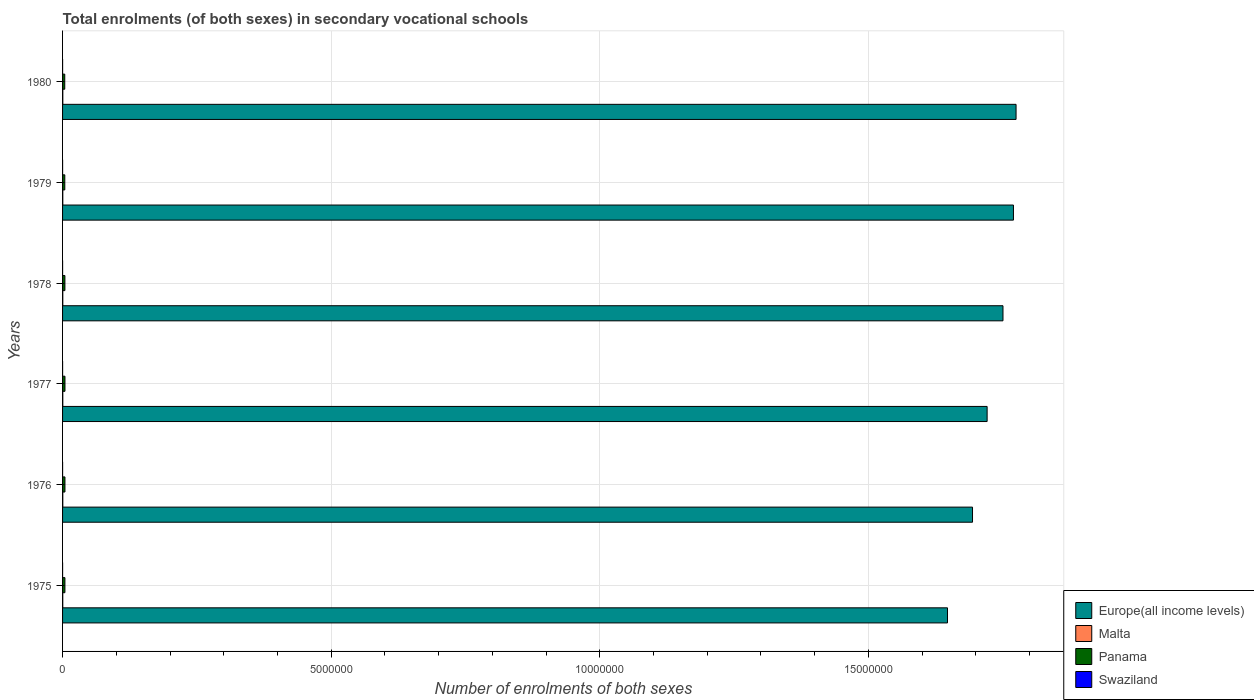How many bars are there on the 4th tick from the top?
Make the answer very short. 4. How many bars are there on the 6th tick from the bottom?
Make the answer very short. 4. What is the label of the 5th group of bars from the top?
Make the answer very short. 1976. What is the number of enrolments in secondary schools in Europe(all income levels) in 1976?
Your answer should be compact. 1.69e+07. Across all years, what is the maximum number of enrolments in secondary schools in Swaziland?
Offer a terse response. 649. Across all years, what is the minimum number of enrolments in secondary schools in Europe(all income levels)?
Your response must be concise. 1.65e+07. In which year was the number of enrolments in secondary schools in Swaziland maximum?
Provide a succinct answer. 1975. In which year was the number of enrolments in secondary schools in Malta minimum?
Ensure brevity in your answer.  1975. What is the total number of enrolments in secondary schools in Swaziland in the graph?
Provide a succinct answer. 2801. What is the difference between the number of enrolments in secondary schools in Europe(all income levels) in 1975 and that in 1978?
Offer a terse response. -1.03e+06. What is the difference between the number of enrolments in secondary schools in Malta in 1975 and the number of enrolments in secondary schools in Europe(all income levels) in 1976?
Provide a short and direct response. -1.69e+07. What is the average number of enrolments in secondary schools in Panama per year?
Your answer should be compact. 4.31e+04. In the year 1979, what is the difference between the number of enrolments in secondary schools in Malta and number of enrolments in secondary schools in Europe(all income levels)?
Provide a succinct answer. -1.77e+07. What is the ratio of the number of enrolments in secondary schools in Panama in 1975 to that in 1980?
Your answer should be compact. 1.07. Is the difference between the number of enrolments in secondary schools in Malta in 1977 and 1980 greater than the difference between the number of enrolments in secondary schools in Europe(all income levels) in 1977 and 1980?
Provide a short and direct response. Yes. What is the difference between the highest and the second highest number of enrolments in secondary schools in Malta?
Give a very brief answer. 231. What is the difference between the highest and the lowest number of enrolments in secondary schools in Swaziland?
Provide a succinct answer. 246. In how many years, is the number of enrolments in secondary schools in Europe(all income levels) greater than the average number of enrolments in secondary schools in Europe(all income levels) taken over all years?
Give a very brief answer. 3. Is the sum of the number of enrolments in secondary schools in Panama in 1975 and 1979 greater than the maximum number of enrolments in secondary schools in Swaziland across all years?
Your answer should be compact. Yes. What does the 3rd bar from the top in 1980 represents?
Offer a very short reply. Malta. What does the 4th bar from the bottom in 1979 represents?
Keep it short and to the point. Swaziland. Are all the bars in the graph horizontal?
Ensure brevity in your answer.  Yes. Does the graph contain any zero values?
Your answer should be very brief. No. What is the title of the graph?
Make the answer very short. Total enrolments (of both sexes) in secondary vocational schools. What is the label or title of the X-axis?
Keep it short and to the point. Number of enrolments of both sexes. What is the label or title of the Y-axis?
Provide a succinct answer. Years. What is the Number of enrolments of both sexes of Europe(all income levels) in 1975?
Provide a succinct answer. 1.65e+07. What is the Number of enrolments of both sexes of Malta in 1975?
Your answer should be very brief. 3663. What is the Number of enrolments of both sexes of Panama in 1975?
Your answer should be compact. 4.38e+04. What is the Number of enrolments of both sexes of Swaziland in 1975?
Give a very brief answer. 649. What is the Number of enrolments of both sexes of Europe(all income levels) in 1976?
Your response must be concise. 1.69e+07. What is the Number of enrolments of both sexes of Malta in 1976?
Offer a terse response. 4387. What is the Number of enrolments of both sexes in Panama in 1976?
Your answer should be very brief. 4.44e+04. What is the Number of enrolments of both sexes of Swaziland in 1976?
Your response must be concise. 472. What is the Number of enrolments of both sexes in Europe(all income levels) in 1977?
Provide a succinct answer. 1.72e+07. What is the Number of enrolments of both sexes of Malta in 1977?
Give a very brief answer. 4332. What is the Number of enrolments of both sexes in Panama in 1977?
Offer a terse response. 4.48e+04. What is the Number of enrolments of both sexes in Swaziland in 1977?
Your answer should be compact. 403. What is the Number of enrolments of both sexes in Europe(all income levels) in 1978?
Your response must be concise. 1.75e+07. What is the Number of enrolments of both sexes in Malta in 1978?
Offer a very short reply. 4397. What is the Number of enrolments of both sexes of Panama in 1978?
Provide a succinct answer. 4.35e+04. What is the Number of enrolments of both sexes of Swaziland in 1978?
Provide a short and direct response. 406. What is the Number of enrolments of both sexes in Europe(all income levels) in 1979?
Your response must be concise. 1.77e+07. What is the Number of enrolments of both sexes of Malta in 1979?
Your answer should be very brief. 4395. What is the Number of enrolments of both sexes of Panama in 1979?
Ensure brevity in your answer.  4.15e+04. What is the Number of enrolments of both sexes of Swaziland in 1979?
Provide a succinct answer. 404. What is the Number of enrolments of both sexes in Europe(all income levels) in 1980?
Make the answer very short. 1.78e+07. What is the Number of enrolments of both sexes in Malta in 1980?
Your answer should be compact. 4628. What is the Number of enrolments of both sexes in Panama in 1980?
Offer a very short reply. 4.08e+04. What is the Number of enrolments of both sexes in Swaziland in 1980?
Offer a terse response. 467. Across all years, what is the maximum Number of enrolments of both sexes in Europe(all income levels)?
Offer a terse response. 1.78e+07. Across all years, what is the maximum Number of enrolments of both sexes in Malta?
Make the answer very short. 4628. Across all years, what is the maximum Number of enrolments of both sexes in Panama?
Your response must be concise. 4.48e+04. Across all years, what is the maximum Number of enrolments of both sexes of Swaziland?
Your answer should be very brief. 649. Across all years, what is the minimum Number of enrolments of both sexes in Europe(all income levels)?
Ensure brevity in your answer.  1.65e+07. Across all years, what is the minimum Number of enrolments of both sexes of Malta?
Provide a succinct answer. 3663. Across all years, what is the minimum Number of enrolments of both sexes of Panama?
Offer a terse response. 4.08e+04. Across all years, what is the minimum Number of enrolments of both sexes in Swaziland?
Provide a short and direct response. 403. What is the total Number of enrolments of both sexes in Europe(all income levels) in the graph?
Offer a terse response. 1.04e+08. What is the total Number of enrolments of both sexes in Malta in the graph?
Your response must be concise. 2.58e+04. What is the total Number of enrolments of both sexes of Panama in the graph?
Provide a short and direct response. 2.59e+05. What is the total Number of enrolments of both sexes of Swaziland in the graph?
Provide a succinct answer. 2801. What is the difference between the Number of enrolments of both sexes of Europe(all income levels) in 1975 and that in 1976?
Ensure brevity in your answer.  -4.66e+05. What is the difference between the Number of enrolments of both sexes of Malta in 1975 and that in 1976?
Offer a terse response. -724. What is the difference between the Number of enrolments of both sexes in Panama in 1975 and that in 1976?
Provide a short and direct response. -632. What is the difference between the Number of enrolments of both sexes in Swaziland in 1975 and that in 1976?
Your response must be concise. 177. What is the difference between the Number of enrolments of both sexes in Europe(all income levels) in 1975 and that in 1977?
Provide a succinct answer. -7.38e+05. What is the difference between the Number of enrolments of both sexes in Malta in 1975 and that in 1977?
Offer a terse response. -669. What is the difference between the Number of enrolments of both sexes in Panama in 1975 and that in 1977?
Ensure brevity in your answer.  -1005. What is the difference between the Number of enrolments of both sexes in Swaziland in 1975 and that in 1977?
Ensure brevity in your answer.  246. What is the difference between the Number of enrolments of both sexes in Europe(all income levels) in 1975 and that in 1978?
Keep it short and to the point. -1.03e+06. What is the difference between the Number of enrolments of both sexes in Malta in 1975 and that in 1978?
Your answer should be very brief. -734. What is the difference between the Number of enrolments of both sexes of Panama in 1975 and that in 1978?
Offer a very short reply. 308. What is the difference between the Number of enrolments of both sexes in Swaziland in 1975 and that in 1978?
Make the answer very short. 243. What is the difference between the Number of enrolments of both sexes in Europe(all income levels) in 1975 and that in 1979?
Offer a terse response. -1.23e+06. What is the difference between the Number of enrolments of both sexes of Malta in 1975 and that in 1979?
Your answer should be very brief. -732. What is the difference between the Number of enrolments of both sexes in Panama in 1975 and that in 1979?
Keep it short and to the point. 2306. What is the difference between the Number of enrolments of both sexes of Swaziland in 1975 and that in 1979?
Make the answer very short. 245. What is the difference between the Number of enrolments of both sexes in Europe(all income levels) in 1975 and that in 1980?
Provide a short and direct response. -1.28e+06. What is the difference between the Number of enrolments of both sexes of Malta in 1975 and that in 1980?
Offer a very short reply. -965. What is the difference between the Number of enrolments of both sexes in Panama in 1975 and that in 1980?
Ensure brevity in your answer.  3040. What is the difference between the Number of enrolments of both sexes of Swaziland in 1975 and that in 1980?
Offer a very short reply. 182. What is the difference between the Number of enrolments of both sexes in Europe(all income levels) in 1976 and that in 1977?
Keep it short and to the point. -2.72e+05. What is the difference between the Number of enrolments of both sexes in Panama in 1976 and that in 1977?
Keep it short and to the point. -373. What is the difference between the Number of enrolments of both sexes in Europe(all income levels) in 1976 and that in 1978?
Your response must be concise. -5.67e+05. What is the difference between the Number of enrolments of both sexes in Panama in 1976 and that in 1978?
Give a very brief answer. 940. What is the difference between the Number of enrolments of both sexes of Europe(all income levels) in 1976 and that in 1979?
Your answer should be compact. -7.62e+05. What is the difference between the Number of enrolments of both sexes of Malta in 1976 and that in 1979?
Ensure brevity in your answer.  -8. What is the difference between the Number of enrolments of both sexes of Panama in 1976 and that in 1979?
Your answer should be very brief. 2938. What is the difference between the Number of enrolments of both sexes of Europe(all income levels) in 1976 and that in 1980?
Offer a terse response. -8.11e+05. What is the difference between the Number of enrolments of both sexes of Malta in 1976 and that in 1980?
Give a very brief answer. -241. What is the difference between the Number of enrolments of both sexes of Panama in 1976 and that in 1980?
Give a very brief answer. 3672. What is the difference between the Number of enrolments of both sexes in Swaziland in 1976 and that in 1980?
Ensure brevity in your answer.  5. What is the difference between the Number of enrolments of both sexes in Europe(all income levels) in 1977 and that in 1978?
Ensure brevity in your answer.  -2.95e+05. What is the difference between the Number of enrolments of both sexes in Malta in 1977 and that in 1978?
Keep it short and to the point. -65. What is the difference between the Number of enrolments of both sexes of Panama in 1977 and that in 1978?
Keep it short and to the point. 1313. What is the difference between the Number of enrolments of both sexes of Europe(all income levels) in 1977 and that in 1979?
Make the answer very short. -4.90e+05. What is the difference between the Number of enrolments of both sexes of Malta in 1977 and that in 1979?
Provide a short and direct response. -63. What is the difference between the Number of enrolments of both sexes of Panama in 1977 and that in 1979?
Keep it short and to the point. 3311. What is the difference between the Number of enrolments of both sexes of Europe(all income levels) in 1977 and that in 1980?
Ensure brevity in your answer.  -5.39e+05. What is the difference between the Number of enrolments of both sexes in Malta in 1977 and that in 1980?
Offer a terse response. -296. What is the difference between the Number of enrolments of both sexes of Panama in 1977 and that in 1980?
Provide a short and direct response. 4045. What is the difference between the Number of enrolments of both sexes in Swaziland in 1977 and that in 1980?
Offer a very short reply. -64. What is the difference between the Number of enrolments of both sexes of Europe(all income levels) in 1978 and that in 1979?
Your answer should be compact. -1.95e+05. What is the difference between the Number of enrolments of both sexes in Malta in 1978 and that in 1979?
Offer a terse response. 2. What is the difference between the Number of enrolments of both sexes of Panama in 1978 and that in 1979?
Provide a short and direct response. 1998. What is the difference between the Number of enrolments of both sexes of Swaziland in 1978 and that in 1979?
Offer a very short reply. 2. What is the difference between the Number of enrolments of both sexes of Europe(all income levels) in 1978 and that in 1980?
Your answer should be very brief. -2.43e+05. What is the difference between the Number of enrolments of both sexes of Malta in 1978 and that in 1980?
Make the answer very short. -231. What is the difference between the Number of enrolments of both sexes in Panama in 1978 and that in 1980?
Keep it short and to the point. 2732. What is the difference between the Number of enrolments of both sexes of Swaziland in 1978 and that in 1980?
Keep it short and to the point. -61. What is the difference between the Number of enrolments of both sexes of Europe(all income levels) in 1979 and that in 1980?
Give a very brief answer. -4.86e+04. What is the difference between the Number of enrolments of both sexes of Malta in 1979 and that in 1980?
Offer a terse response. -233. What is the difference between the Number of enrolments of both sexes of Panama in 1979 and that in 1980?
Ensure brevity in your answer.  734. What is the difference between the Number of enrolments of both sexes in Swaziland in 1979 and that in 1980?
Provide a succinct answer. -63. What is the difference between the Number of enrolments of both sexes in Europe(all income levels) in 1975 and the Number of enrolments of both sexes in Malta in 1976?
Provide a succinct answer. 1.65e+07. What is the difference between the Number of enrolments of both sexes in Europe(all income levels) in 1975 and the Number of enrolments of both sexes in Panama in 1976?
Offer a very short reply. 1.64e+07. What is the difference between the Number of enrolments of both sexes in Europe(all income levels) in 1975 and the Number of enrolments of both sexes in Swaziland in 1976?
Ensure brevity in your answer.  1.65e+07. What is the difference between the Number of enrolments of both sexes in Malta in 1975 and the Number of enrolments of both sexes in Panama in 1976?
Give a very brief answer. -4.08e+04. What is the difference between the Number of enrolments of both sexes in Malta in 1975 and the Number of enrolments of both sexes in Swaziland in 1976?
Your answer should be compact. 3191. What is the difference between the Number of enrolments of both sexes of Panama in 1975 and the Number of enrolments of both sexes of Swaziland in 1976?
Your response must be concise. 4.33e+04. What is the difference between the Number of enrolments of both sexes of Europe(all income levels) in 1975 and the Number of enrolments of both sexes of Malta in 1977?
Your answer should be very brief. 1.65e+07. What is the difference between the Number of enrolments of both sexes of Europe(all income levels) in 1975 and the Number of enrolments of both sexes of Panama in 1977?
Your answer should be very brief. 1.64e+07. What is the difference between the Number of enrolments of both sexes of Europe(all income levels) in 1975 and the Number of enrolments of both sexes of Swaziland in 1977?
Give a very brief answer. 1.65e+07. What is the difference between the Number of enrolments of both sexes in Malta in 1975 and the Number of enrolments of both sexes in Panama in 1977?
Ensure brevity in your answer.  -4.12e+04. What is the difference between the Number of enrolments of both sexes of Malta in 1975 and the Number of enrolments of both sexes of Swaziland in 1977?
Offer a terse response. 3260. What is the difference between the Number of enrolments of both sexes of Panama in 1975 and the Number of enrolments of both sexes of Swaziland in 1977?
Your answer should be compact. 4.34e+04. What is the difference between the Number of enrolments of both sexes of Europe(all income levels) in 1975 and the Number of enrolments of both sexes of Malta in 1978?
Give a very brief answer. 1.65e+07. What is the difference between the Number of enrolments of both sexes of Europe(all income levels) in 1975 and the Number of enrolments of both sexes of Panama in 1978?
Provide a short and direct response. 1.64e+07. What is the difference between the Number of enrolments of both sexes of Europe(all income levels) in 1975 and the Number of enrolments of both sexes of Swaziland in 1978?
Provide a succinct answer. 1.65e+07. What is the difference between the Number of enrolments of both sexes in Malta in 1975 and the Number of enrolments of both sexes in Panama in 1978?
Give a very brief answer. -3.98e+04. What is the difference between the Number of enrolments of both sexes in Malta in 1975 and the Number of enrolments of both sexes in Swaziland in 1978?
Offer a terse response. 3257. What is the difference between the Number of enrolments of both sexes in Panama in 1975 and the Number of enrolments of both sexes in Swaziland in 1978?
Offer a terse response. 4.34e+04. What is the difference between the Number of enrolments of both sexes of Europe(all income levels) in 1975 and the Number of enrolments of both sexes of Malta in 1979?
Your answer should be compact. 1.65e+07. What is the difference between the Number of enrolments of both sexes in Europe(all income levels) in 1975 and the Number of enrolments of both sexes in Panama in 1979?
Provide a succinct answer. 1.64e+07. What is the difference between the Number of enrolments of both sexes in Europe(all income levels) in 1975 and the Number of enrolments of both sexes in Swaziland in 1979?
Provide a short and direct response. 1.65e+07. What is the difference between the Number of enrolments of both sexes in Malta in 1975 and the Number of enrolments of both sexes in Panama in 1979?
Your answer should be very brief. -3.78e+04. What is the difference between the Number of enrolments of both sexes in Malta in 1975 and the Number of enrolments of both sexes in Swaziland in 1979?
Your answer should be compact. 3259. What is the difference between the Number of enrolments of both sexes of Panama in 1975 and the Number of enrolments of both sexes of Swaziland in 1979?
Offer a very short reply. 4.34e+04. What is the difference between the Number of enrolments of both sexes in Europe(all income levels) in 1975 and the Number of enrolments of both sexes in Malta in 1980?
Provide a succinct answer. 1.65e+07. What is the difference between the Number of enrolments of both sexes of Europe(all income levels) in 1975 and the Number of enrolments of both sexes of Panama in 1980?
Provide a succinct answer. 1.64e+07. What is the difference between the Number of enrolments of both sexes of Europe(all income levels) in 1975 and the Number of enrolments of both sexes of Swaziland in 1980?
Keep it short and to the point. 1.65e+07. What is the difference between the Number of enrolments of both sexes of Malta in 1975 and the Number of enrolments of both sexes of Panama in 1980?
Give a very brief answer. -3.71e+04. What is the difference between the Number of enrolments of both sexes in Malta in 1975 and the Number of enrolments of both sexes in Swaziland in 1980?
Offer a terse response. 3196. What is the difference between the Number of enrolments of both sexes in Panama in 1975 and the Number of enrolments of both sexes in Swaziland in 1980?
Offer a terse response. 4.34e+04. What is the difference between the Number of enrolments of both sexes of Europe(all income levels) in 1976 and the Number of enrolments of both sexes of Malta in 1977?
Offer a terse response. 1.69e+07. What is the difference between the Number of enrolments of both sexes in Europe(all income levels) in 1976 and the Number of enrolments of both sexes in Panama in 1977?
Keep it short and to the point. 1.69e+07. What is the difference between the Number of enrolments of both sexes in Europe(all income levels) in 1976 and the Number of enrolments of both sexes in Swaziland in 1977?
Give a very brief answer. 1.69e+07. What is the difference between the Number of enrolments of both sexes in Malta in 1976 and the Number of enrolments of both sexes in Panama in 1977?
Provide a short and direct response. -4.04e+04. What is the difference between the Number of enrolments of both sexes of Malta in 1976 and the Number of enrolments of both sexes of Swaziland in 1977?
Ensure brevity in your answer.  3984. What is the difference between the Number of enrolments of both sexes of Panama in 1976 and the Number of enrolments of both sexes of Swaziland in 1977?
Your response must be concise. 4.40e+04. What is the difference between the Number of enrolments of both sexes of Europe(all income levels) in 1976 and the Number of enrolments of both sexes of Malta in 1978?
Make the answer very short. 1.69e+07. What is the difference between the Number of enrolments of both sexes of Europe(all income levels) in 1976 and the Number of enrolments of both sexes of Panama in 1978?
Provide a short and direct response. 1.69e+07. What is the difference between the Number of enrolments of both sexes of Europe(all income levels) in 1976 and the Number of enrolments of both sexes of Swaziland in 1978?
Offer a very short reply. 1.69e+07. What is the difference between the Number of enrolments of both sexes in Malta in 1976 and the Number of enrolments of both sexes in Panama in 1978?
Provide a succinct answer. -3.91e+04. What is the difference between the Number of enrolments of both sexes of Malta in 1976 and the Number of enrolments of both sexes of Swaziland in 1978?
Your answer should be compact. 3981. What is the difference between the Number of enrolments of both sexes of Panama in 1976 and the Number of enrolments of both sexes of Swaziland in 1978?
Provide a short and direct response. 4.40e+04. What is the difference between the Number of enrolments of both sexes of Europe(all income levels) in 1976 and the Number of enrolments of both sexes of Malta in 1979?
Provide a succinct answer. 1.69e+07. What is the difference between the Number of enrolments of both sexes in Europe(all income levels) in 1976 and the Number of enrolments of both sexes in Panama in 1979?
Make the answer very short. 1.69e+07. What is the difference between the Number of enrolments of both sexes in Europe(all income levels) in 1976 and the Number of enrolments of both sexes in Swaziland in 1979?
Give a very brief answer. 1.69e+07. What is the difference between the Number of enrolments of both sexes in Malta in 1976 and the Number of enrolments of both sexes in Panama in 1979?
Give a very brief answer. -3.71e+04. What is the difference between the Number of enrolments of both sexes of Malta in 1976 and the Number of enrolments of both sexes of Swaziland in 1979?
Make the answer very short. 3983. What is the difference between the Number of enrolments of both sexes in Panama in 1976 and the Number of enrolments of both sexes in Swaziland in 1979?
Ensure brevity in your answer.  4.40e+04. What is the difference between the Number of enrolments of both sexes in Europe(all income levels) in 1976 and the Number of enrolments of both sexes in Malta in 1980?
Keep it short and to the point. 1.69e+07. What is the difference between the Number of enrolments of both sexes of Europe(all income levels) in 1976 and the Number of enrolments of both sexes of Panama in 1980?
Offer a very short reply. 1.69e+07. What is the difference between the Number of enrolments of both sexes of Europe(all income levels) in 1976 and the Number of enrolments of both sexes of Swaziland in 1980?
Give a very brief answer. 1.69e+07. What is the difference between the Number of enrolments of both sexes in Malta in 1976 and the Number of enrolments of both sexes in Panama in 1980?
Give a very brief answer. -3.64e+04. What is the difference between the Number of enrolments of both sexes in Malta in 1976 and the Number of enrolments of both sexes in Swaziland in 1980?
Provide a short and direct response. 3920. What is the difference between the Number of enrolments of both sexes of Panama in 1976 and the Number of enrolments of both sexes of Swaziland in 1980?
Ensure brevity in your answer.  4.40e+04. What is the difference between the Number of enrolments of both sexes in Europe(all income levels) in 1977 and the Number of enrolments of both sexes in Malta in 1978?
Provide a short and direct response. 1.72e+07. What is the difference between the Number of enrolments of both sexes of Europe(all income levels) in 1977 and the Number of enrolments of both sexes of Panama in 1978?
Give a very brief answer. 1.72e+07. What is the difference between the Number of enrolments of both sexes in Europe(all income levels) in 1977 and the Number of enrolments of both sexes in Swaziland in 1978?
Provide a succinct answer. 1.72e+07. What is the difference between the Number of enrolments of both sexes in Malta in 1977 and the Number of enrolments of both sexes in Panama in 1978?
Offer a terse response. -3.92e+04. What is the difference between the Number of enrolments of both sexes in Malta in 1977 and the Number of enrolments of both sexes in Swaziland in 1978?
Keep it short and to the point. 3926. What is the difference between the Number of enrolments of both sexes in Panama in 1977 and the Number of enrolments of both sexes in Swaziland in 1978?
Make the answer very short. 4.44e+04. What is the difference between the Number of enrolments of both sexes of Europe(all income levels) in 1977 and the Number of enrolments of both sexes of Malta in 1979?
Provide a succinct answer. 1.72e+07. What is the difference between the Number of enrolments of both sexes in Europe(all income levels) in 1977 and the Number of enrolments of both sexes in Panama in 1979?
Keep it short and to the point. 1.72e+07. What is the difference between the Number of enrolments of both sexes in Europe(all income levels) in 1977 and the Number of enrolments of both sexes in Swaziland in 1979?
Give a very brief answer. 1.72e+07. What is the difference between the Number of enrolments of both sexes in Malta in 1977 and the Number of enrolments of both sexes in Panama in 1979?
Offer a terse response. -3.72e+04. What is the difference between the Number of enrolments of both sexes of Malta in 1977 and the Number of enrolments of both sexes of Swaziland in 1979?
Offer a terse response. 3928. What is the difference between the Number of enrolments of both sexes of Panama in 1977 and the Number of enrolments of both sexes of Swaziland in 1979?
Offer a very short reply. 4.44e+04. What is the difference between the Number of enrolments of both sexes of Europe(all income levels) in 1977 and the Number of enrolments of both sexes of Malta in 1980?
Your response must be concise. 1.72e+07. What is the difference between the Number of enrolments of both sexes of Europe(all income levels) in 1977 and the Number of enrolments of both sexes of Panama in 1980?
Give a very brief answer. 1.72e+07. What is the difference between the Number of enrolments of both sexes of Europe(all income levels) in 1977 and the Number of enrolments of both sexes of Swaziland in 1980?
Your answer should be compact. 1.72e+07. What is the difference between the Number of enrolments of both sexes in Malta in 1977 and the Number of enrolments of both sexes in Panama in 1980?
Provide a short and direct response. -3.64e+04. What is the difference between the Number of enrolments of both sexes in Malta in 1977 and the Number of enrolments of both sexes in Swaziland in 1980?
Make the answer very short. 3865. What is the difference between the Number of enrolments of both sexes of Panama in 1977 and the Number of enrolments of both sexes of Swaziland in 1980?
Offer a very short reply. 4.44e+04. What is the difference between the Number of enrolments of both sexes in Europe(all income levels) in 1978 and the Number of enrolments of both sexes in Malta in 1979?
Offer a very short reply. 1.75e+07. What is the difference between the Number of enrolments of both sexes in Europe(all income levels) in 1978 and the Number of enrolments of both sexes in Panama in 1979?
Your response must be concise. 1.75e+07. What is the difference between the Number of enrolments of both sexes in Europe(all income levels) in 1978 and the Number of enrolments of both sexes in Swaziland in 1979?
Keep it short and to the point. 1.75e+07. What is the difference between the Number of enrolments of both sexes of Malta in 1978 and the Number of enrolments of both sexes of Panama in 1979?
Offer a very short reply. -3.71e+04. What is the difference between the Number of enrolments of both sexes of Malta in 1978 and the Number of enrolments of both sexes of Swaziland in 1979?
Ensure brevity in your answer.  3993. What is the difference between the Number of enrolments of both sexes in Panama in 1978 and the Number of enrolments of both sexes in Swaziland in 1979?
Give a very brief answer. 4.31e+04. What is the difference between the Number of enrolments of both sexes of Europe(all income levels) in 1978 and the Number of enrolments of both sexes of Malta in 1980?
Provide a succinct answer. 1.75e+07. What is the difference between the Number of enrolments of both sexes of Europe(all income levels) in 1978 and the Number of enrolments of both sexes of Panama in 1980?
Offer a very short reply. 1.75e+07. What is the difference between the Number of enrolments of both sexes in Europe(all income levels) in 1978 and the Number of enrolments of both sexes in Swaziland in 1980?
Your response must be concise. 1.75e+07. What is the difference between the Number of enrolments of both sexes in Malta in 1978 and the Number of enrolments of both sexes in Panama in 1980?
Give a very brief answer. -3.64e+04. What is the difference between the Number of enrolments of both sexes of Malta in 1978 and the Number of enrolments of both sexes of Swaziland in 1980?
Provide a short and direct response. 3930. What is the difference between the Number of enrolments of both sexes of Panama in 1978 and the Number of enrolments of both sexes of Swaziland in 1980?
Provide a succinct answer. 4.30e+04. What is the difference between the Number of enrolments of both sexes of Europe(all income levels) in 1979 and the Number of enrolments of both sexes of Malta in 1980?
Provide a short and direct response. 1.77e+07. What is the difference between the Number of enrolments of both sexes of Europe(all income levels) in 1979 and the Number of enrolments of both sexes of Panama in 1980?
Your answer should be very brief. 1.77e+07. What is the difference between the Number of enrolments of both sexes of Europe(all income levels) in 1979 and the Number of enrolments of both sexes of Swaziland in 1980?
Your answer should be compact. 1.77e+07. What is the difference between the Number of enrolments of both sexes of Malta in 1979 and the Number of enrolments of both sexes of Panama in 1980?
Provide a succinct answer. -3.64e+04. What is the difference between the Number of enrolments of both sexes of Malta in 1979 and the Number of enrolments of both sexes of Swaziland in 1980?
Provide a succinct answer. 3928. What is the difference between the Number of enrolments of both sexes in Panama in 1979 and the Number of enrolments of both sexes in Swaziland in 1980?
Offer a very short reply. 4.10e+04. What is the average Number of enrolments of both sexes of Europe(all income levels) per year?
Your answer should be very brief. 1.73e+07. What is the average Number of enrolments of both sexes of Malta per year?
Offer a very short reply. 4300.33. What is the average Number of enrolments of both sexes in Panama per year?
Your answer should be compact. 4.31e+04. What is the average Number of enrolments of both sexes in Swaziland per year?
Make the answer very short. 466.83. In the year 1975, what is the difference between the Number of enrolments of both sexes in Europe(all income levels) and Number of enrolments of both sexes in Malta?
Your response must be concise. 1.65e+07. In the year 1975, what is the difference between the Number of enrolments of both sexes in Europe(all income levels) and Number of enrolments of both sexes in Panama?
Provide a short and direct response. 1.64e+07. In the year 1975, what is the difference between the Number of enrolments of both sexes in Europe(all income levels) and Number of enrolments of both sexes in Swaziland?
Your response must be concise. 1.65e+07. In the year 1975, what is the difference between the Number of enrolments of both sexes in Malta and Number of enrolments of both sexes in Panama?
Make the answer very short. -4.02e+04. In the year 1975, what is the difference between the Number of enrolments of both sexes in Malta and Number of enrolments of both sexes in Swaziland?
Give a very brief answer. 3014. In the year 1975, what is the difference between the Number of enrolments of both sexes of Panama and Number of enrolments of both sexes of Swaziland?
Ensure brevity in your answer.  4.32e+04. In the year 1976, what is the difference between the Number of enrolments of both sexes of Europe(all income levels) and Number of enrolments of both sexes of Malta?
Make the answer very short. 1.69e+07. In the year 1976, what is the difference between the Number of enrolments of both sexes in Europe(all income levels) and Number of enrolments of both sexes in Panama?
Provide a succinct answer. 1.69e+07. In the year 1976, what is the difference between the Number of enrolments of both sexes in Europe(all income levels) and Number of enrolments of both sexes in Swaziland?
Your answer should be very brief. 1.69e+07. In the year 1976, what is the difference between the Number of enrolments of both sexes of Malta and Number of enrolments of both sexes of Panama?
Make the answer very short. -4.01e+04. In the year 1976, what is the difference between the Number of enrolments of both sexes of Malta and Number of enrolments of both sexes of Swaziland?
Give a very brief answer. 3915. In the year 1976, what is the difference between the Number of enrolments of both sexes of Panama and Number of enrolments of both sexes of Swaziland?
Make the answer very short. 4.40e+04. In the year 1977, what is the difference between the Number of enrolments of both sexes of Europe(all income levels) and Number of enrolments of both sexes of Malta?
Ensure brevity in your answer.  1.72e+07. In the year 1977, what is the difference between the Number of enrolments of both sexes of Europe(all income levels) and Number of enrolments of both sexes of Panama?
Give a very brief answer. 1.72e+07. In the year 1977, what is the difference between the Number of enrolments of both sexes of Europe(all income levels) and Number of enrolments of both sexes of Swaziland?
Your response must be concise. 1.72e+07. In the year 1977, what is the difference between the Number of enrolments of both sexes of Malta and Number of enrolments of both sexes of Panama?
Provide a short and direct response. -4.05e+04. In the year 1977, what is the difference between the Number of enrolments of both sexes in Malta and Number of enrolments of both sexes in Swaziland?
Provide a succinct answer. 3929. In the year 1977, what is the difference between the Number of enrolments of both sexes of Panama and Number of enrolments of both sexes of Swaziland?
Provide a short and direct response. 4.44e+04. In the year 1978, what is the difference between the Number of enrolments of both sexes of Europe(all income levels) and Number of enrolments of both sexes of Malta?
Give a very brief answer. 1.75e+07. In the year 1978, what is the difference between the Number of enrolments of both sexes in Europe(all income levels) and Number of enrolments of both sexes in Panama?
Your response must be concise. 1.75e+07. In the year 1978, what is the difference between the Number of enrolments of both sexes in Europe(all income levels) and Number of enrolments of both sexes in Swaziland?
Ensure brevity in your answer.  1.75e+07. In the year 1978, what is the difference between the Number of enrolments of both sexes in Malta and Number of enrolments of both sexes in Panama?
Provide a succinct answer. -3.91e+04. In the year 1978, what is the difference between the Number of enrolments of both sexes of Malta and Number of enrolments of both sexes of Swaziland?
Ensure brevity in your answer.  3991. In the year 1978, what is the difference between the Number of enrolments of both sexes of Panama and Number of enrolments of both sexes of Swaziland?
Offer a terse response. 4.31e+04. In the year 1979, what is the difference between the Number of enrolments of both sexes of Europe(all income levels) and Number of enrolments of both sexes of Malta?
Your answer should be very brief. 1.77e+07. In the year 1979, what is the difference between the Number of enrolments of both sexes of Europe(all income levels) and Number of enrolments of both sexes of Panama?
Ensure brevity in your answer.  1.77e+07. In the year 1979, what is the difference between the Number of enrolments of both sexes in Europe(all income levels) and Number of enrolments of both sexes in Swaziland?
Provide a succinct answer. 1.77e+07. In the year 1979, what is the difference between the Number of enrolments of both sexes in Malta and Number of enrolments of both sexes in Panama?
Your answer should be compact. -3.71e+04. In the year 1979, what is the difference between the Number of enrolments of both sexes of Malta and Number of enrolments of both sexes of Swaziland?
Your answer should be compact. 3991. In the year 1979, what is the difference between the Number of enrolments of both sexes in Panama and Number of enrolments of both sexes in Swaziland?
Your answer should be compact. 4.11e+04. In the year 1980, what is the difference between the Number of enrolments of both sexes of Europe(all income levels) and Number of enrolments of both sexes of Malta?
Ensure brevity in your answer.  1.77e+07. In the year 1980, what is the difference between the Number of enrolments of both sexes in Europe(all income levels) and Number of enrolments of both sexes in Panama?
Provide a succinct answer. 1.77e+07. In the year 1980, what is the difference between the Number of enrolments of both sexes in Europe(all income levels) and Number of enrolments of both sexes in Swaziland?
Keep it short and to the point. 1.78e+07. In the year 1980, what is the difference between the Number of enrolments of both sexes in Malta and Number of enrolments of both sexes in Panama?
Give a very brief answer. -3.61e+04. In the year 1980, what is the difference between the Number of enrolments of both sexes in Malta and Number of enrolments of both sexes in Swaziland?
Keep it short and to the point. 4161. In the year 1980, what is the difference between the Number of enrolments of both sexes in Panama and Number of enrolments of both sexes in Swaziland?
Offer a very short reply. 4.03e+04. What is the ratio of the Number of enrolments of both sexes in Europe(all income levels) in 1975 to that in 1976?
Offer a terse response. 0.97. What is the ratio of the Number of enrolments of both sexes of Malta in 1975 to that in 1976?
Offer a very short reply. 0.83. What is the ratio of the Number of enrolments of both sexes of Panama in 1975 to that in 1976?
Your answer should be very brief. 0.99. What is the ratio of the Number of enrolments of both sexes in Swaziland in 1975 to that in 1976?
Your answer should be very brief. 1.38. What is the ratio of the Number of enrolments of both sexes of Europe(all income levels) in 1975 to that in 1977?
Provide a succinct answer. 0.96. What is the ratio of the Number of enrolments of both sexes in Malta in 1975 to that in 1977?
Your answer should be very brief. 0.85. What is the ratio of the Number of enrolments of both sexes of Panama in 1975 to that in 1977?
Give a very brief answer. 0.98. What is the ratio of the Number of enrolments of both sexes of Swaziland in 1975 to that in 1977?
Ensure brevity in your answer.  1.61. What is the ratio of the Number of enrolments of both sexes of Europe(all income levels) in 1975 to that in 1978?
Provide a succinct answer. 0.94. What is the ratio of the Number of enrolments of both sexes in Malta in 1975 to that in 1978?
Your answer should be very brief. 0.83. What is the ratio of the Number of enrolments of both sexes in Panama in 1975 to that in 1978?
Provide a succinct answer. 1.01. What is the ratio of the Number of enrolments of both sexes of Swaziland in 1975 to that in 1978?
Offer a very short reply. 1.6. What is the ratio of the Number of enrolments of both sexes of Europe(all income levels) in 1975 to that in 1979?
Your answer should be compact. 0.93. What is the ratio of the Number of enrolments of both sexes of Malta in 1975 to that in 1979?
Your answer should be compact. 0.83. What is the ratio of the Number of enrolments of both sexes of Panama in 1975 to that in 1979?
Keep it short and to the point. 1.06. What is the ratio of the Number of enrolments of both sexes in Swaziland in 1975 to that in 1979?
Give a very brief answer. 1.61. What is the ratio of the Number of enrolments of both sexes of Europe(all income levels) in 1975 to that in 1980?
Offer a terse response. 0.93. What is the ratio of the Number of enrolments of both sexes of Malta in 1975 to that in 1980?
Offer a very short reply. 0.79. What is the ratio of the Number of enrolments of both sexes in Panama in 1975 to that in 1980?
Your answer should be compact. 1.07. What is the ratio of the Number of enrolments of both sexes of Swaziland in 1975 to that in 1980?
Give a very brief answer. 1.39. What is the ratio of the Number of enrolments of both sexes of Europe(all income levels) in 1976 to that in 1977?
Keep it short and to the point. 0.98. What is the ratio of the Number of enrolments of both sexes in Malta in 1976 to that in 1977?
Make the answer very short. 1.01. What is the ratio of the Number of enrolments of both sexes of Panama in 1976 to that in 1977?
Your answer should be very brief. 0.99. What is the ratio of the Number of enrolments of both sexes of Swaziland in 1976 to that in 1977?
Offer a very short reply. 1.17. What is the ratio of the Number of enrolments of both sexes of Europe(all income levels) in 1976 to that in 1978?
Offer a very short reply. 0.97. What is the ratio of the Number of enrolments of both sexes in Panama in 1976 to that in 1978?
Keep it short and to the point. 1.02. What is the ratio of the Number of enrolments of both sexes in Swaziland in 1976 to that in 1978?
Offer a terse response. 1.16. What is the ratio of the Number of enrolments of both sexes of Europe(all income levels) in 1976 to that in 1979?
Ensure brevity in your answer.  0.96. What is the ratio of the Number of enrolments of both sexes in Panama in 1976 to that in 1979?
Keep it short and to the point. 1.07. What is the ratio of the Number of enrolments of both sexes of Swaziland in 1976 to that in 1979?
Give a very brief answer. 1.17. What is the ratio of the Number of enrolments of both sexes in Europe(all income levels) in 1976 to that in 1980?
Your response must be concise. 0.95. What is the ratio of the Number of enrolments of both sexes of Malta in 1976 to that in 1980?
Provide a succinct answer. 0.95. What is the ratio of the Number of enrolments of both sexes in Panama in 1976 to that in 1980?
Give a very brief answer. 1.09. What is the ratio of the Number of enrolments of both sexes in Swaziland in 1976 to that in 1980?
Give a very brief answer. 1.01. What is the ratio of the Number of enrolments of both sexes of Europe(all income levels) in 1977 to that in 1978?
Offer a very short reply. 0.98. What is the ratio of the Number of enrolments of both sexes in Malta in 1977 to that in 1978?
Your answer should be compact. 0.99. What is the ratio of the Number of enrolments of both sexes in Panama in 1977 to that in 1978?
Your answer should be very brief. 1.03. What is the ratio of the Number of enrolments of both sexes of Europe(all income levels) in 1977 to that in 1979?
Your answer should be very brief. 0.97. What is the ratio of the Number of enrolments of both sexes in Malta in 1977 to that in 1979?
Your answer should be compact. 0.99. What is the ratio of the Number of enrolments of both sexes in Panama in 1977 to that in 1979?
Your response must be concise. 1.08. What is the ratio of the Number of enrolments of both sexes in Swaziland in 1977 to that in 1979?
Ensure brevity in your answer.  1. What is the ratio of the Number of enrolments of both sexes of Europe(all income levels) in 1977 to that in 1980?
Offer a terse response. 0.97. What is the ratio of the Number of enrolments of both sexes in Malta in 1977 to that in 1980?
Give a very brief answer. 0.94. What is the ratio of the Number of enrolments of both sexes of Panama in 1977 to that in 1980?
Give a very brief answer. 1.1. What is the ratio of the Number of enrolments of both sexes of Swaziland in 1977 to that in 1980?
Your response must be concise. 0.86. What is the ratio of the Number of enrolments of both sexes of Malta in 1978 to that in 1979?
Ensure brevity in your answer.  1. What is the ratio of the Number of enrolments of both sexes of Panama in 1978 to that in 1979?
Provide a succinct answer. 1.05. What is the ratio of the Number of enrolments of both sexes of Swaziland in 1978 to that in 1979?
Provide a succinct answer. 1. What is the ratio of the Number of enrolments of both sexes in Europe(all income levels) in 1978 to that in 1980?
Offer a terse response. 0.99. What is the ratio of the Number of enrolments of both sexes of Malta in 1978 to that in 1980?
Your answer should be compact. 0.95. What is the ratio of the Number of enrolments of both sexes in Panama in 1978 to that in 1980?
Give a very brief answer. 1.07. What is the ratio of the Number of enrolments of both sexes of Swaziland in 1978 to that in 1980?
Provide a succinct answer. 0.87. What is the ratio of the Number of enrolments of both sexes of Europe(all income levels) in 1979 to that in 1980?
Ensure brevity in your answer.  1. What is the ratio of the Number of enrolments of both sexes in Malta in 1979 to that in 1980?
Offer a terse response. 0.95. What is the ratio of the Number of enrolments of both sexes in Panama in 1979 to that in 1980?
Provide a succinct answer. 1.02. What is the ratio of the Number of enrolments of both sexes of Swaziland in 1979 to that in 1980?
Provide a short and direct response. 0.87. What is the difference between the highest and the second highest Number of enrolments of both sexes in Europe(all income levels)?
Provide a succinct answer. 4.86e+04. What is the difference between the highest and the second highest Number of enrolments of both sexes in Malta?
Keep it short and to the point. 231. What is the difference between the highest and the second highest Number of enrolments of both sexes in Panama?
Provide a short and direct response. 373. What is the difference between the highest and the second highest Number of enrolments of both sexes of Swaziland?
Your answer should be compact. 177. What is the difference between the highest and the lowest Number of enrolments of both sexes of Europe(all income levels)?
Keep it short and to the point. 1.28e+06. What is the difference between the highest and the lowest Number of enrolments of both sexes in Malta?
Ensure brevity in your answer.  965. What is the difference between the highest and the lowest Number of enrolments of both sexes of Panama?
Provide a succinct answer. 4045. What is the difference between the highest and the lowest Number of enrolments of both sexes of Swaziland?
Ensure brevity in your answer.  246. 